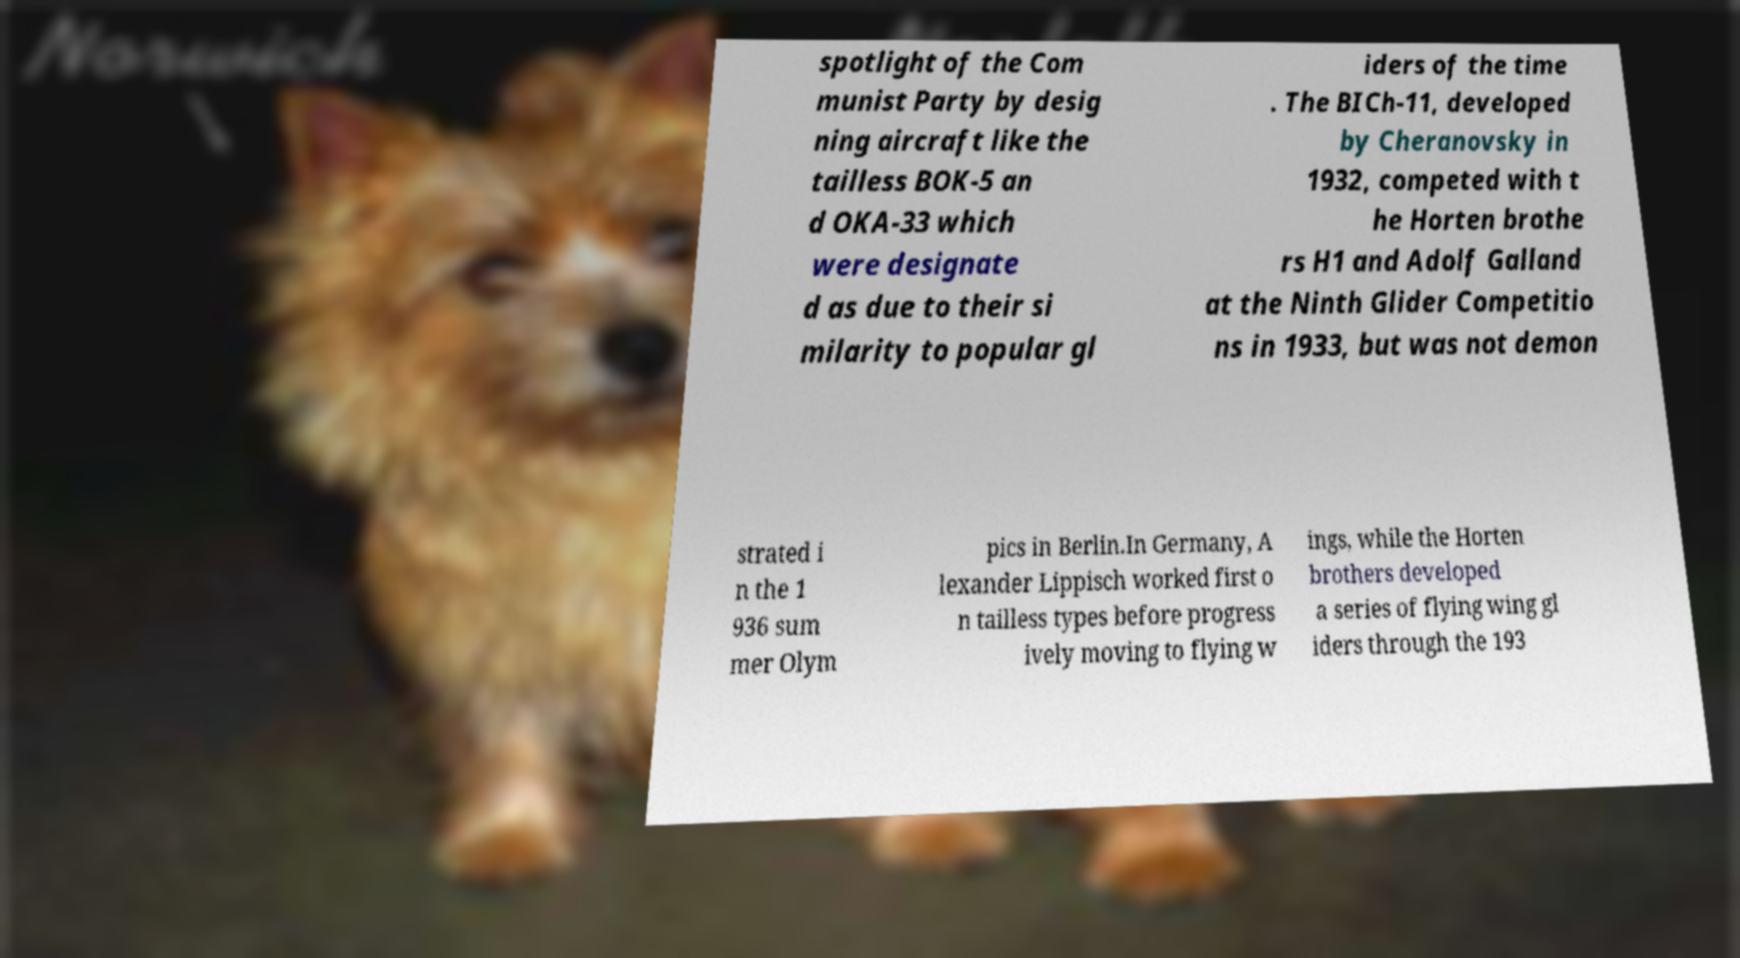What messages or text are displayed in this image? I need them in a readable, typed format. spotlight of the Com munist Party by desig ning aircraft like the tailless BOK-5 an d OKA-33 which were designate d as due to their si milarity to popular gl iders of the time . The BICh-11, developed by Cheranovsky in 1932, competed with t he Horten brothe rs H1 and Adolf Galland at the Ninth Glider Competitio ns in 1933, but was not demon strated i n the 1 936 sum mer Olym pics in Berlin.In Germany, A lexander Lippisch worked first o n tailless types before progress ively moving to flying w ings, while the Horten brothers developed a series of flying wing gl iders through the 193 